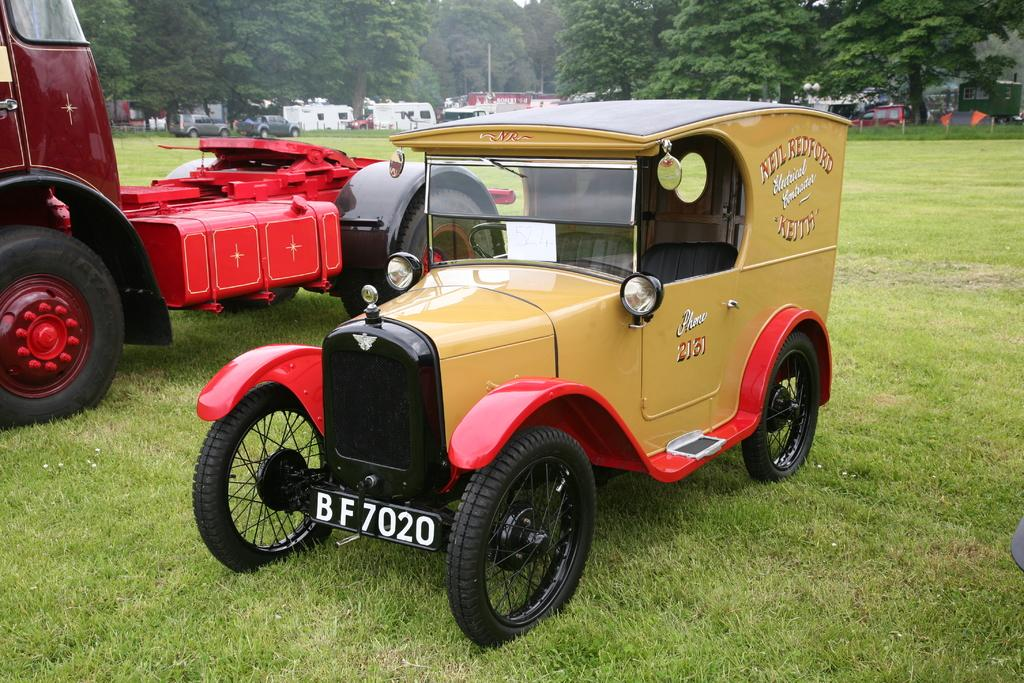What types of vehicles are on the ground in the image? There are vehicles on the ground in the ground in the image, but the specific types are not mentioned. What can be seen in the background of the image? In the background of the image, there are trees, poles, grass, and other objects. Can you describe the ground in the image? The ground in the image has vehicles on it, but the specific nature of the ground is not mentioned. What type of dirt can be seen on the manager's shoes in the image? There is no manager or shoes present in the image, so it is not possible to determine the type of dirt on any shoes. 